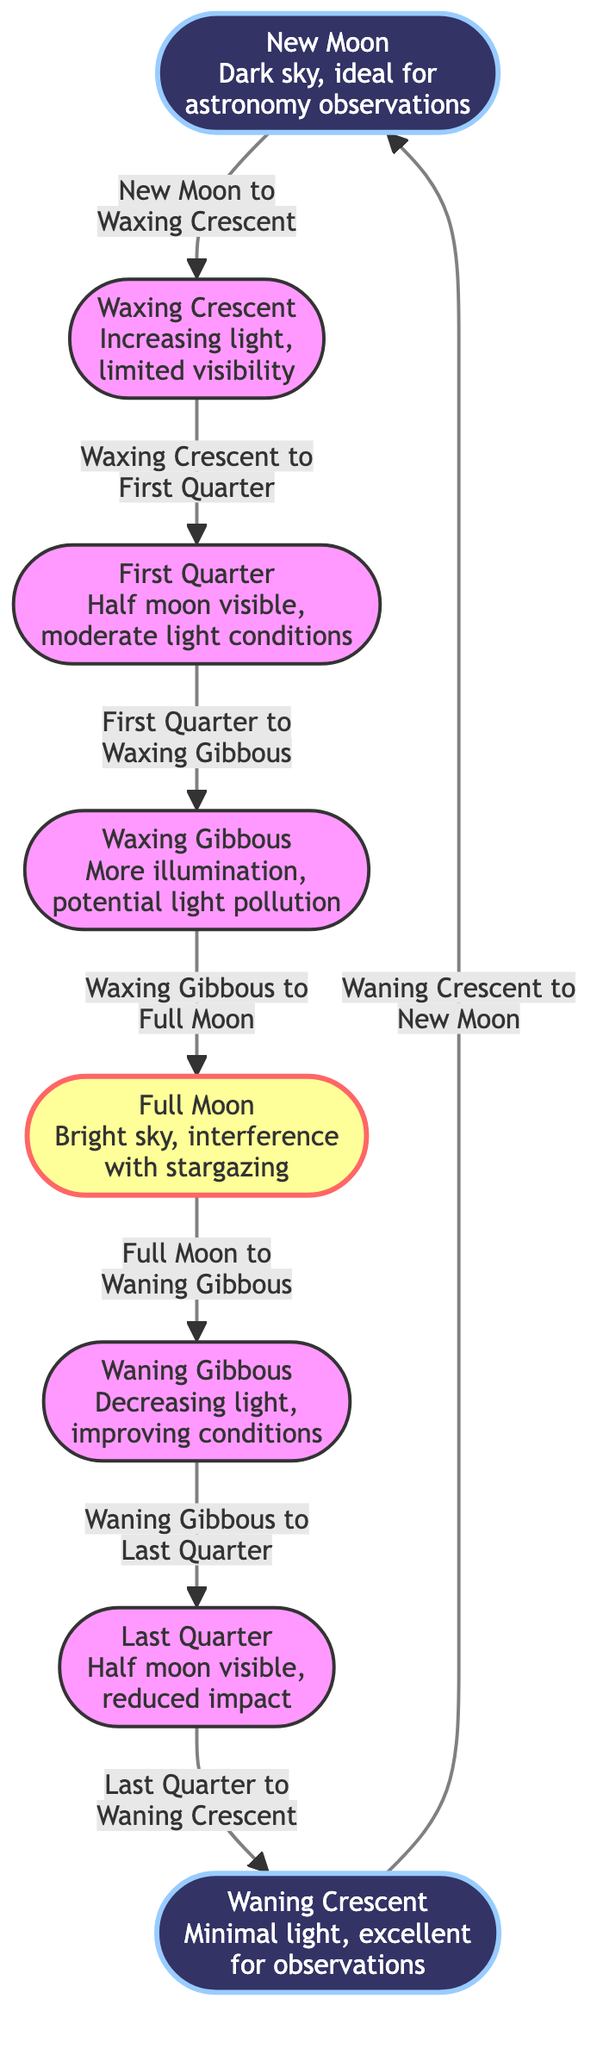What phase follows the New Moon? According to the flow of the diagram, the phases progress from New Moon to Waxing Crescent, as indicated by the arrow connecting these two nodes.
Answer: Waxing Crescent How many total phases of the Moon are represented in the diagram? By counting the nodes in the diagram, there are a total of eight distinct phases of the Moon, each represented by a separate node.
Answer: Eight What type of conditions are expected during a Full Moon? The diagram states that during a Full Moon, conditions are bright and there is interference with stargazing, as noted in the description of this phase.
Answer: Bright sky, interference What phase appears after Waning Gibbous? Following the arrow in the diagram, the phase that comes after Waning Gibbous is Last Quarter, as shown in the transition between these two nodes.
Answer: Last Quarter Which phases are categorized as "dark"? According to the diagram, the phases classified as dark include New Moon and Waning Crescent, as these two nodes are highlighted with a dark style.
Answer: New Moon, Waning Crescent Between which two phases does the most light pollution occur? From the diagram, the transition from Waxing Gibbous to Full Moon is where more illumination occurs, leading to potential light pollution as noted in the description of the Waxing Gibbous phase.
Answer: Waxing Gibbous to Full Moon What phase has a moderate impact on visibility? The First Quarter phase is described in the diagram as having moderate light conditions, indicating a balanced level of visibility for nighttime operations.
Answer: First Quarter Which phase has the best conditions for astronomy observations? The diagram identifies New Moon and Waning Crescent as periods where the conditions are excellent for astronomy observations, with minimal light present.
Answer: New Moon, Waning Crescent What happens to visibility during the transition from Full Moon to Waning Gibbous? The diagram shows that during the transition from Full Moon to Waning Gibbous, the light is decreasing, which improves visibility conditions for stargazing compared to the Full Moon.
Answer: Improving conditions 